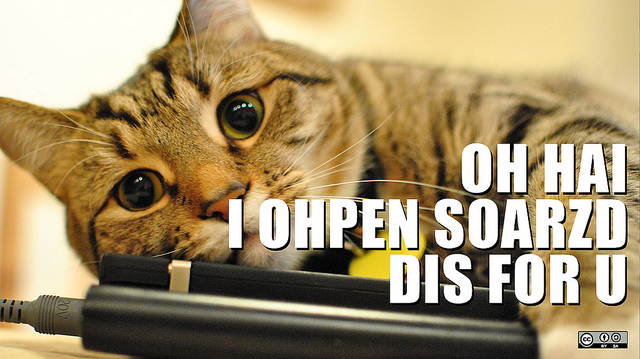Please identify all text content in this image. OH HAI I OHPENOHPEN SOARZD CC U FOR DIS 20V 